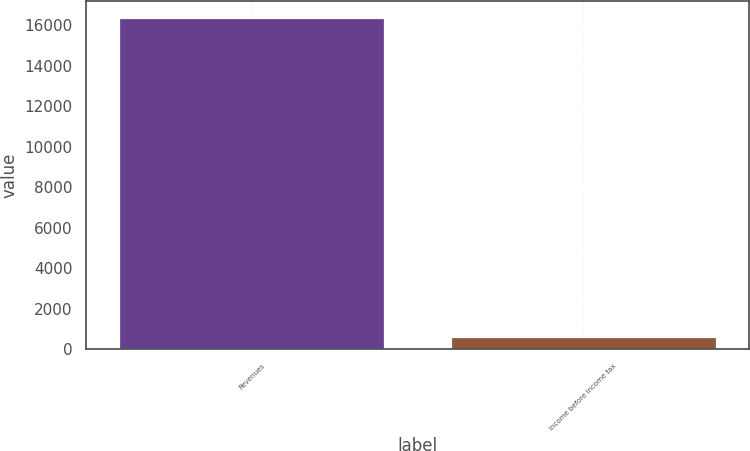Convert chart. <chart><loc_0><loc_0><loc_500><loc_500><bar_chart><fcel>Revenues<fcel>Income before income tax<nl><fcel>16371<fcel>622<nl></chart> 